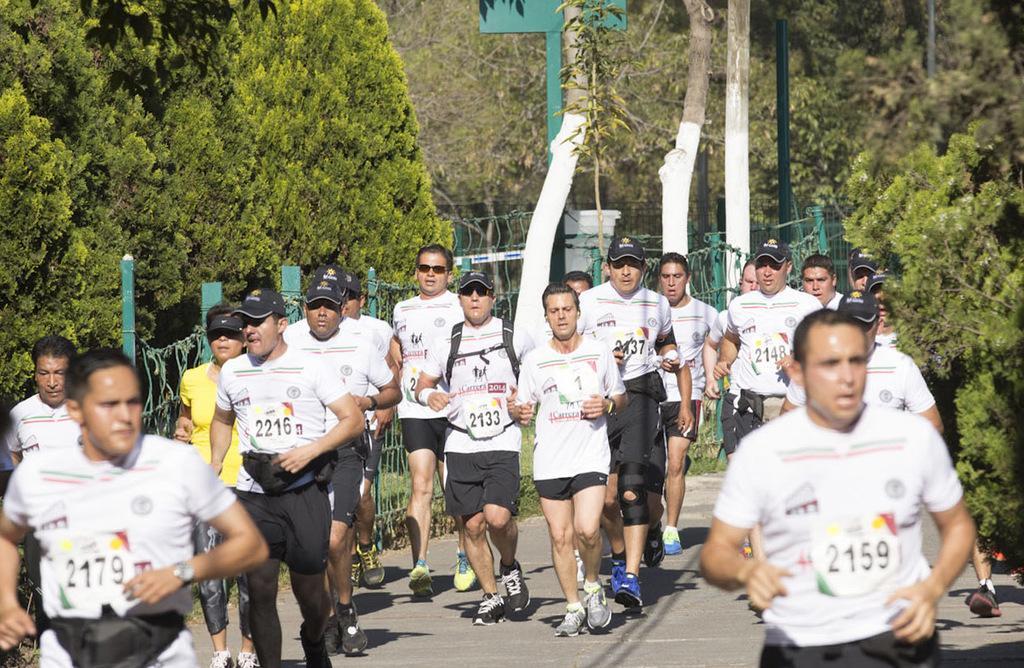Please provide a concise description of this image. In the foreground of the picture there are people running on the road. On the right there are trees. On the left there are trees. In the center of the picture there are trees, railing, grass and poles. It is sunny. 